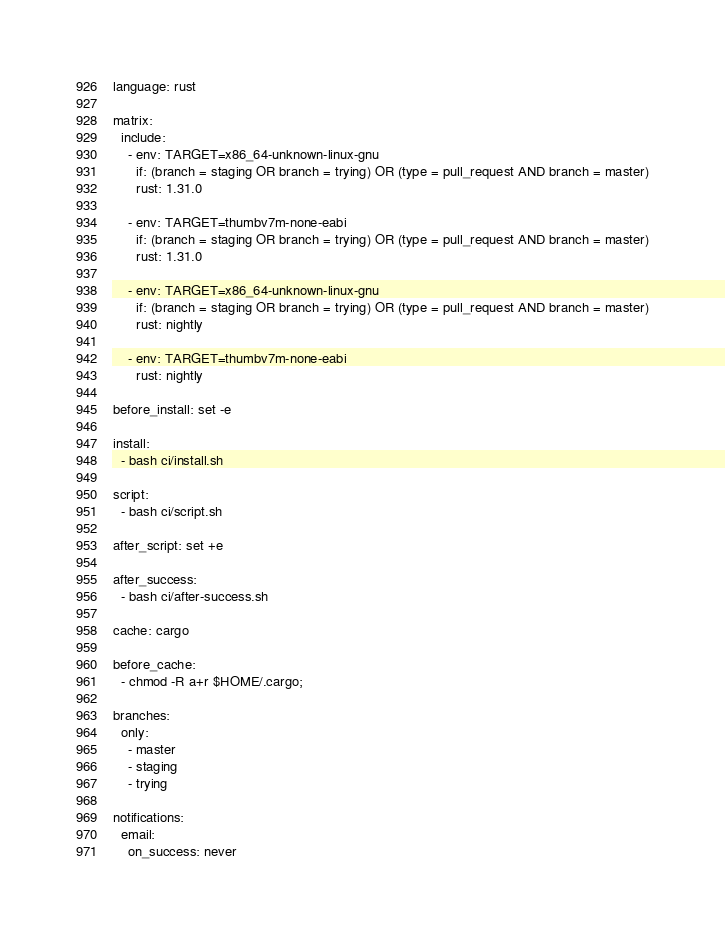<code> <loc_0><loc_0><loc_500><loc_500><_YAML_>language: rust

matrix:
  include:
    - env: TARGET=x86_64-unknown-linux-gnu
      if: (branch = staging OR branch = trying) OR (type = pull_request AND branch = master)
      rust: 1.31.0

    - env: TARGET=thumbv7m-none-eabi
      if: (branch = staging OR branch = trying) OR (type = pull_request AND branch = master)
      rust: 1.31.0

    - env: TARGET=x86_64-unknown-linux-gnu
      if: (branch = staging OR branch = trying) OR (type = pull_request AND branch = master)
      rust: nightly

    - env: TARGET=thumbv7m-none-eabi
      rust: nightly

before_install: set -e

install:
  - bash ci/install.sh

script:
  - bash ci/script.sh

after_script: set +e

after_success:
  - bash ci/after-success.sh

cache: cargo

before_cache:
  - chmod -R a+r $HOME/.cargo;

branches:
  only:
    - master
    - staging
    - trying

notifications:
  email:
    on_success: never
</code> 